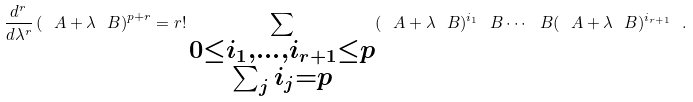Convert formula to latex. <formula><loc_0><loc_0><loc_500><loc_500>\frac { d ^ { r } } { d \lambda ^ { r } } \left ( \ A + \lambda \ B \right ) ^ { p + r } = r ! \sum _ { \substack { 0 \leq i _ { 1 } , \dots , i _ { r + 1 } \leq p \\ \sum _ { j } i _ { j } = p } } ( \ A + \lambda \ B ) ^ { i _ { 1 } } \ B \cdots \ B ( \ A + \lambda \ B ) ^ { i _ { r + 1 } } \ .</formula> 